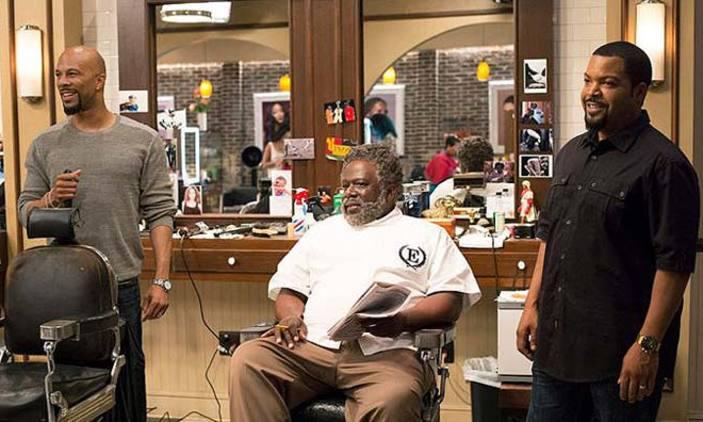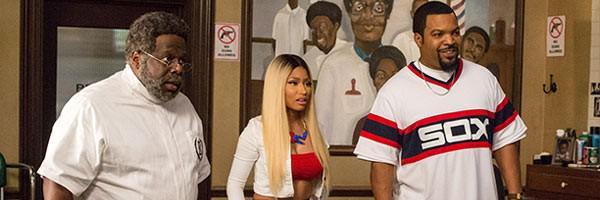The first image is the image on the left, the second image is the image on the right. For the images shown, is this caption "A barber is working on a former US president in one of the images" true? Answer yes or no. No. The first image is the image on the left, the second image is the image on the right. Examine the images to the left and right. Is the description "A barbershop scene includes at least two real non-smiling women." accurate? Answer yes or no. No. 